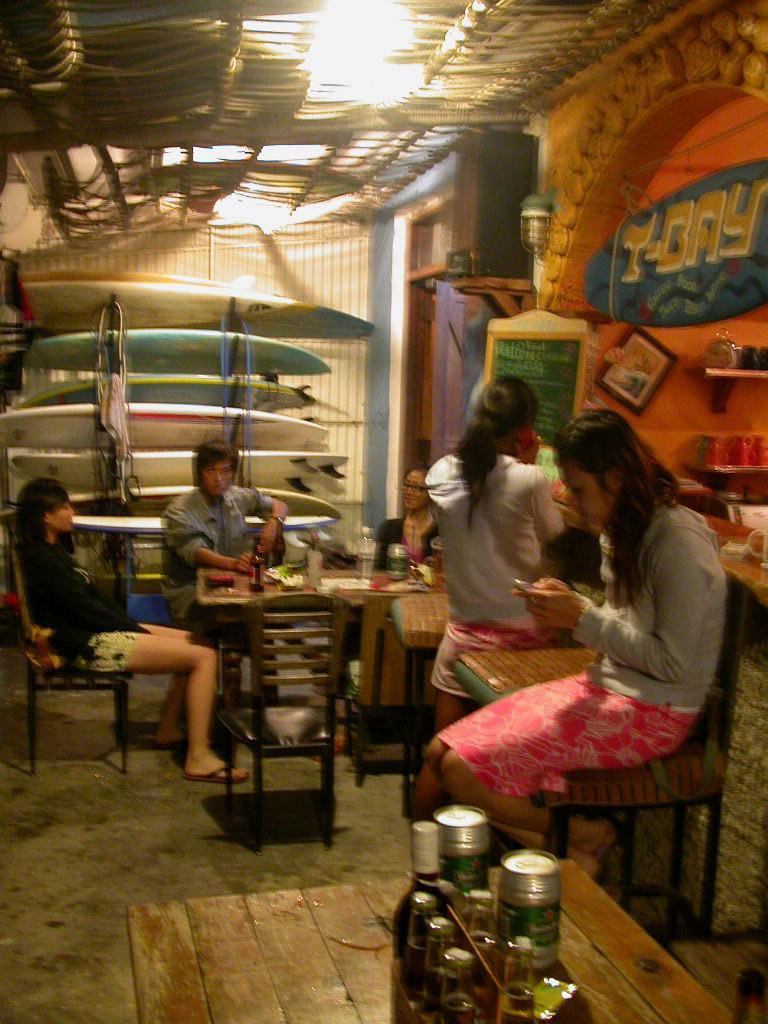How many people are in the image? There are 5 persons in the image. What are the positions of the majority of the people in the image? Four of the persons are sitting. What is the position of the remaining person in the image? One person is standing. What type of furniture is present in the image? There are chairs and tables in the image. What can be found on the tables? There are objects on the tables. What type of sky is visible in the image? There is no sky visible in the image; it appears to be an indoor setting. How many teams are participating in the activity shown in the image? There is no indication of a team-based activity in the image; it simply shows five people in various positions. 